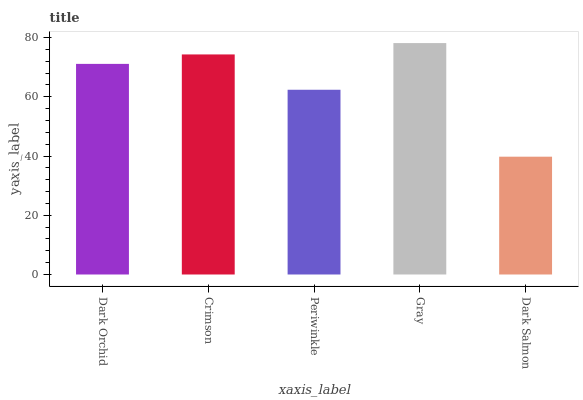Is Dark Salmon the minimum?
Answer yes or no. Yes. Is Gray the maximum?
Answer yes or no. Yes. Is Crimson the minimum?
Answer yes or no. No. Is Crimson the maximum?
Answer yes or no. No. Is Crimson greater than Dark Orchid?
Answer yes or no. Yes. Is Dark Orchid less than Crimson?
Answer yes or no. Yes. Is Dark Orchid greater than Crimson?
Answer yes or no. No. Is Crimson less than Dark Orchid?
Answer yes or no. No. Is Dark Orchid the high median?
Answer yes or no. Yes. Is Dark Orchid the low median?
Answer yes or no. Yes. Is Dark Salmon the high median?
Answer yes or no. No. Is Periwinkle the low median?
Answer yes or no. No. 